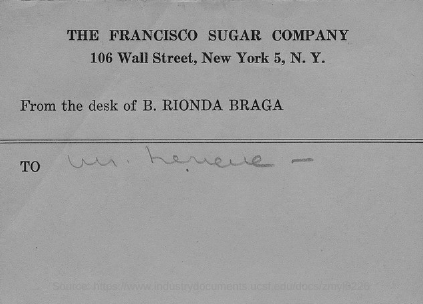Specify some key components in this picture. The desk belongs to B. Rionda Braga. 